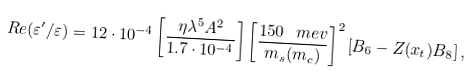Convert formula to latex. <formula><loc_0><loc_0><loc_500><loc_500>R e ( \varepsilon ^ { \prime } / \varepsilon ) = 1 2 \cdot 1 0 ^ { - 4 } \left [ \frac { \eta \lambda ^ { 5 } A ^ { 2 } } { 1 . 7 \cdot 1 0 ^ { - 4 } } \right ] \left [ \frac { 1 5 0 \, \ m e v } { m _ { s } ( m _ { c } ) } \right ] ^ { 2 } \left [ B _ { 6 } - Z ( x _ { t } ) B _ { 8 } \right ] ,</formula> 